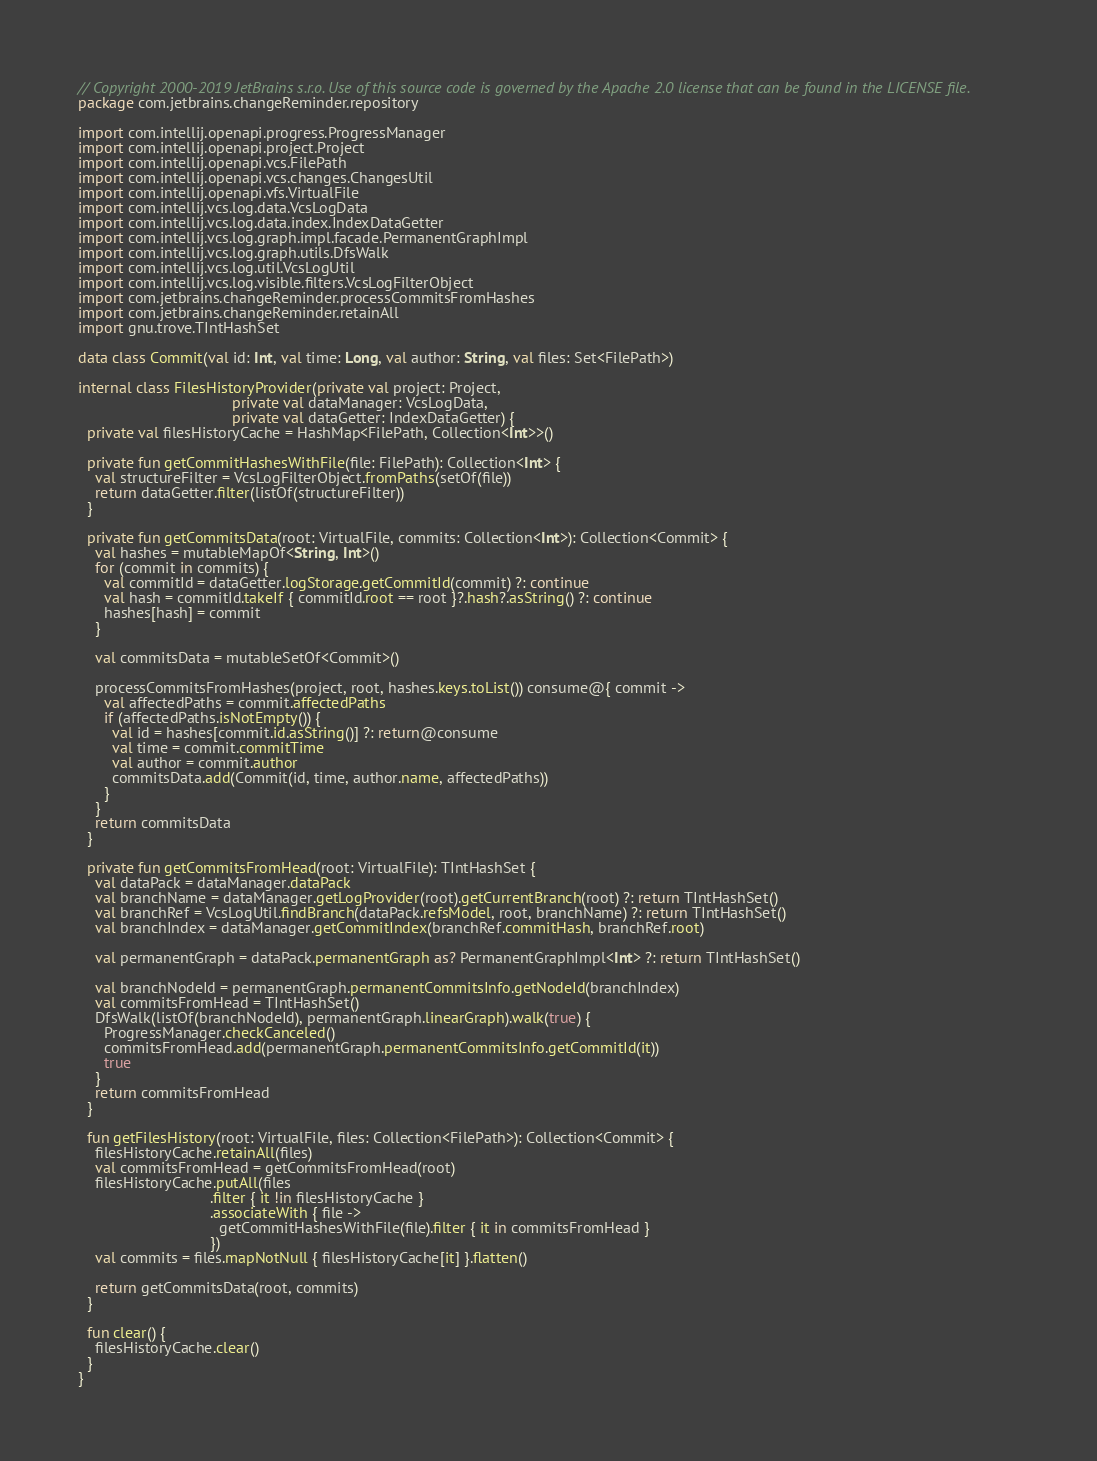Convert code to text. <code><loc_0><loc_0><loc_500><loc_500><_Kotlin_>// Copyright 2000-2019 JetBrains s.r.o. Use of this source code is governed by the Apache 2.0 license that can be found in the LICENSE file.
package com.jetbrains.changeReminder.repository

import com.intellij.openapi.progress.ProgressManager
import com.intellij.openapi.project.Project
import com.intellij.openapi.vcs.FilePath
import com.intellij.openapi.vcs.changes.ChangesUtil
import com.intellij.openapi.vfs.VirtualFile
import com.intellij.vcs.log.data.VcsLogData
import com.intellij.vcs.log.data.index.IndexDataGetter
import com.intellij.vcs.log.graph.impl.facade.PermanentGraphImpl
import com.intellij.vcs.log.graph.utils.DfsWalk
import com.intellij.vcs.log.util.VcsLogUtil
import com.intellij.vcs.log.visible.filters.VcsLogFilterObject
import com.jetbrains.changeReminder.processCommitsFromHashes
import com.jetbrains.changeReminder.retainAll
import gnu.trove.TIntHashSet

data class Commit(val id: Int, val time: Long, val author: String, val files: Set<FilePath>)

internal class FilesHistoryProvider(private val project: Project,
                                    private val dataManager: VcsLogData,
                                    private val dataGetter: IndexDataGetter) {
  private val filesHistoryCache = HashMap<FilePath, Collection<Int>>()

  private fun getCommitHashesWithFile(file: FilePath): Collection<Int> {
    val structureFilter = VcsLogFilterObject.fromPaths(setOf(file))
    return dataGetter.filter(listOf(structureFilter))
  }

  private fun getCommitsData(root: VirtualFile, commits: Collection<Int>): Collection<Commit> {
    val hashes = mutableMapOf<String, Int>()
    for (commit in commits) {
      val commitId = dataGetter.logStorage.getCommitId(commit) ?: continue
      val hash = commitId.takeIf { commitId.root == root }?.hash?.asString() ?: continue
      hashes[hash] = commit
    }

    val commitsData = mutableSetOf<Commit>()

    processCommitsFromHashes(project, root, hashes.keys.toList()) consume@{ commit ->
      val affectedPaths = commit.affectedPaths
      if (affectedPaths.isNotEmpty()) {
        val id = hashes[commit.id.asString()] ?: return@consume
        val time = commit.commitTime
        val author = commit.author
        commitsData.add(Commit(id, time, author.name, affectedPaths))
      }
    }
    return commitsData
  }

  private fun getCommitsFromHead(root: VirtualFile): TIntHashSet {
    val dataPack = dataManager.dataPack
    val branchName = dataManager.getLogProvider(root).getCurrentBranch(root) ?: return TIntHashSet()
    val branchRef = VcsLogUtil.findBranch(dataPack.refsModel, root, branchName) ?: return TIntHashSet()
    val branchIndex = dataManager.getCommitIndex(branchRef.commitHash, branchRef.root)

    val permanentGraph = dataPack.permanentGraph as? PermanentGraphImpl<Int> ?: return TIntHashSet()

    val branchNodeId = permanentGraph.permanentCommitsInfo.getNodeId(branchIndex)
    val commitsFromHead = TIntHashSet()
    DfsWalk(listOf(branchNodeId), permanentGraph.linearGraph).walk(true) {
      ProgressManager.checkCanceled()
      commitsFromHead.add(permanentGraph.permanentCommitsInfo.getCommitId(it))
      true
    }
    return commitsFromHead
  }

  fun getFilesHistory(root: VirtualFile, files: Collection<FilePath>): Collection<Commit> {
    filesHistoryCache.retainAll(files)
    val commitsFromHead = getCommitsFromHead(root)
    filesHistoryCache.putAll(files
                               .filter { it !in filesHistoryCache }
                               .associateWith { file ->
                                 getCommitHashesWithFile(file).filter { it in commitsFromHead }
                               })
    val commits = files.mapNotNull { filesHistoryCache[it] }.flatten()

    return getCommitsData(root, commits)
  }

  fun clear() {
    filesHistoryCache.clear()
  }
}</code> 